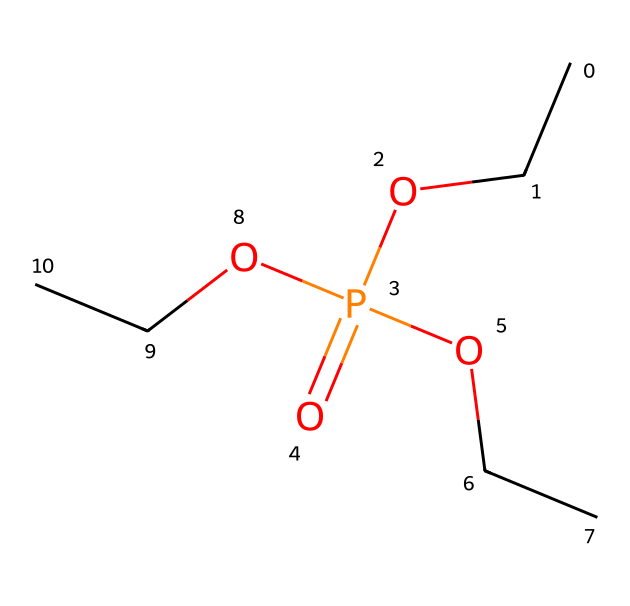how many carbon atoms are present in triethyl phosphate? The SMILES representation CCOP(=O)(OCC)OCC indicates the presence of carbon atoms. Each "CC" represents a two-carbon unit (ethyl group). There are three ethyl groups, which means there are 3 × 2 = 6 carbon atoms in total.
Answer: 6 what is the total number of oxygen atoms in this compound? In the given SMILES, "O" appears three times: once in the phosphate group (P(=O)) and twice as part of the ethyl groups (OCC). Therefore, the total number of oxygen atoms is three.
Answer: 4 which atom is at the center of the triethyl phosphate molecule? The SMILES structure indicates that the phosphorus atom (P) is bonded to oxygen and carbon atoms, showing that it is the central atom of the molecule.
Answer: phosphorus how many hydrogen atoms are connected to the carbon atoms in triethyl phosphate? Each ethyl group (CC) has five hydrogen atoms attached (C2H5). Since there are three ethyl groups, the total is 3 × 5 = 15 hydrogen atoms.
Answer: 15 what type of compound is triethyl phosphate categorized as? Triethyl phosphate is classified as an organophosphate compound because it contains phosphorus bonded to carbon atoms as part of ester functionality.
Answer: organophosphate does triethyl phosphate have a polar or non-polar nature? The presence of the phosphate group (with multiple oxygen atoms) indicates that the molecule has polar characteristics due to the uneven distribution of electron density.
Answer: polar 